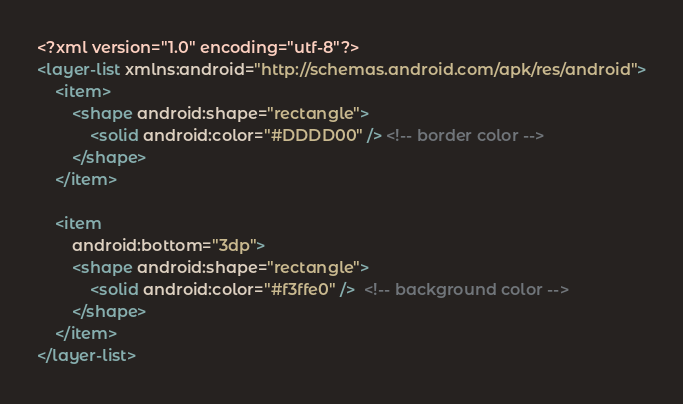<code> <loc_0><loc_0><loc_500><loc_500><_XML_><?xml version="1.0" encoding="utf-8"?>
<layer-list xmlns:android="http://schemas.android.com/apk/res/android">
    <item>
        <shape android:shape="rectangle">
            <solid android:color="#DDDD00" /> <!-- border color -->
        </shape>
    </item>

    <item
        android:bottom="3dp">
        <shape android:shape="rectangle">
            <solid android:color="#f3ffe0" />  <!-- background color -->
        </shape>
    </item>
</layer-list></code> 